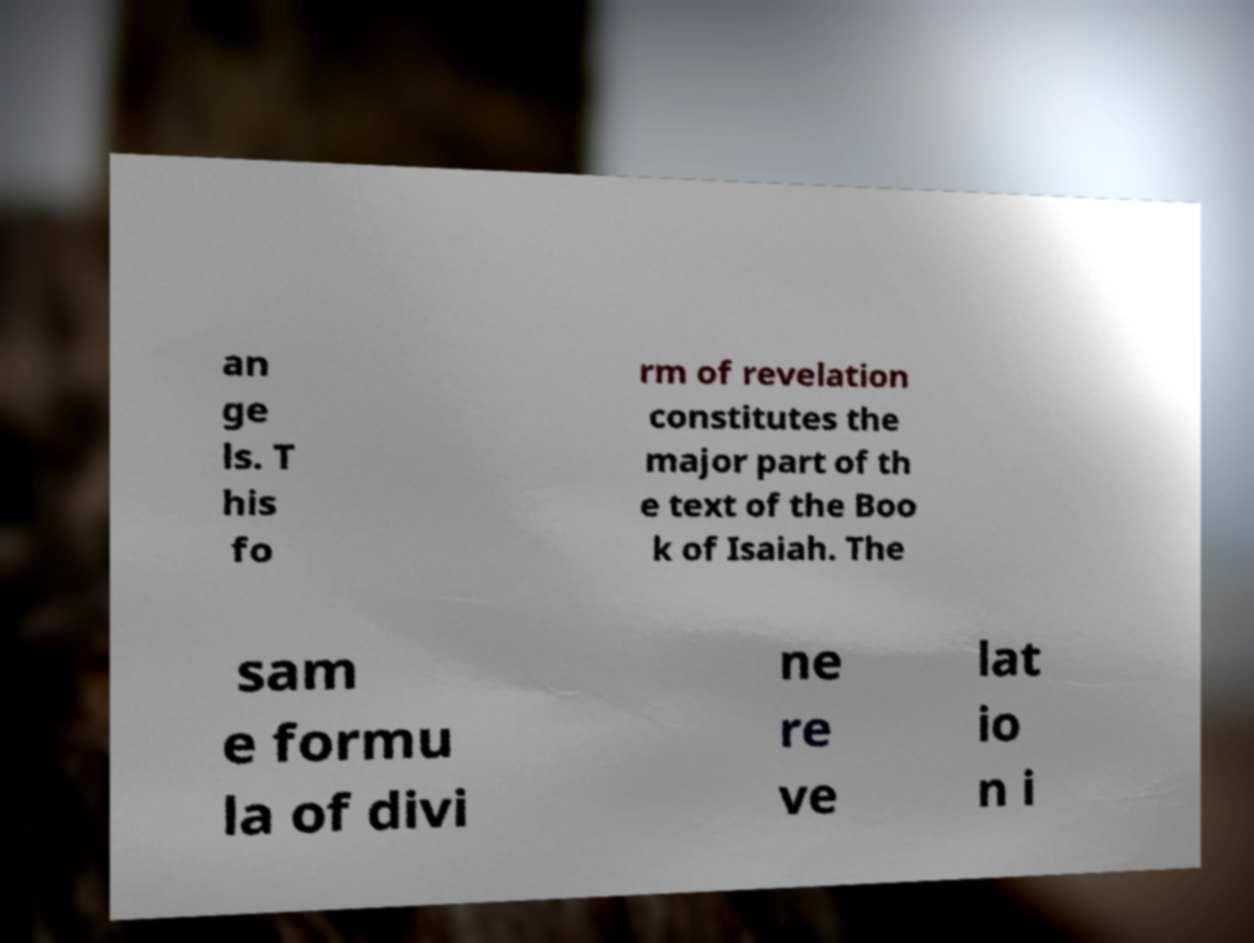Please identify and transcribe the text found in this image. an ge ls. T his fo rm of revelation constitutes the major part of th e text of the Boo k of Isaiah. The sam e formu la of divi ne re ve lat io n i 